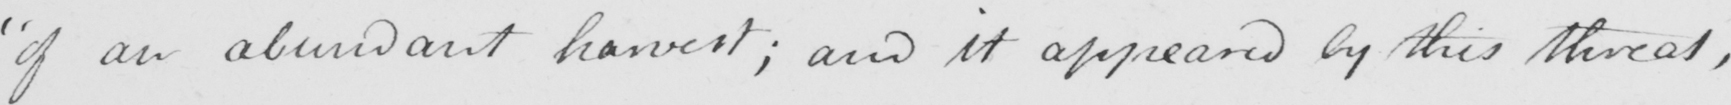What is written in this line of handwriting? " of an abundant harvest ; and it appeared by this threat , 